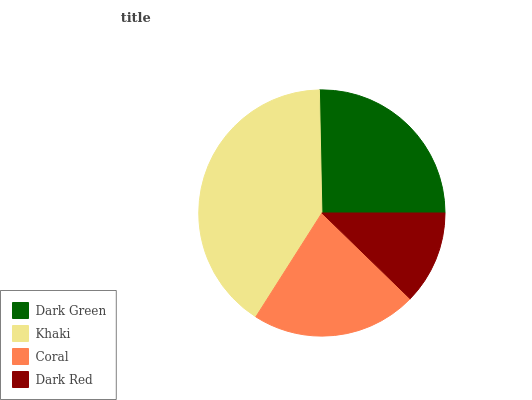Is Dark Red the minimum?
Answer yes or no. Yes. Is Khaki the maximum?
Answer yes or no. Yes. Is Coral the minimum?
Answer yes or no. No. Is Coral the maximum?
Answer yes or no. No. Is Khaki greater than Coral?
Answer yes or no. Yes. Is Coral less than Khaki?
Answer yes or no. Yes. Is Coral greater than Khaki?
Answer yes or no. No. Is Khaki less than Coral?
Answer yes or no. No. Is Dark Green the high median?
Answer yes or no. Yes. Is Coral the low median?
Answer yes or no. Yes. Is Coral the high median?
Answer yes or no. No. Is Dark Red the low median?
Answer yes or no. No. 